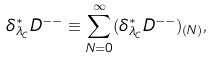<formula> <loc_0><loc_0><loc_500><loc_500>\delta ^ { * } _ { \lambda _ { C } } D ^ { - - } \equiv \sum _ { N = 0 } ^ { \infty } ( \delta ^ { * } _ { \lambda _ { C } } D ^ { - - } ) _ { ( N ) } ,</formula> 